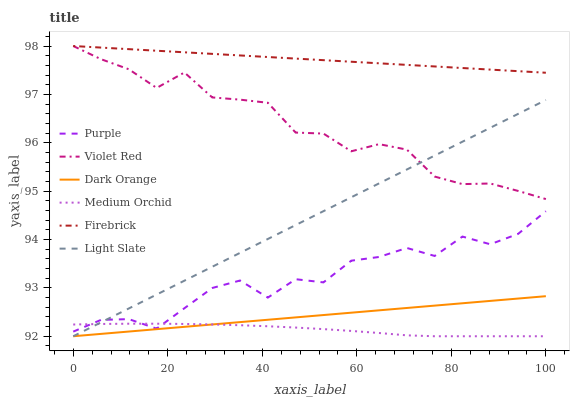Does Medium Orchid have the minimum area under the curve?
Answer yes or no. Yes. Does Firebrick have the maximum area under the curve?
Answer yes or no. Yes. Does Violet Red have the minimum area under the curve?
Answer yes or no. No. Does Violet Red have the maximum area under the curve?
Answer yes or no. No. Is Dark Orange the smoothest?
Answer yes or no. Yes. Is Purple the roughest?
Answer yes or no. Yes. Is Violet Red the smoothest?
Answer yes or no. No. Is Violet Red the roughest?
Answer yes or no. No. Does Dark Orange have the lowest value?
Answer yes or no. Yes. Does Violet Red have the lowest value?
Answer yes or no. No. Does Firebrick have the highest value?
Answer yes or no. Yes. Does Purple have the highest value?
Answer yes or no. No. Is Purple less than Firebrick?
Answer yes or no. Yes. Is Firebrick greater than Medium Orchid?
Answer yes or no. Yes. Does Dark Orange intersect Light Slate?
Answer yes or no. Yes. Is Dark Orange less than Light Slate?
Answer yes or no. No. Is Dark Orange greater than Light Slate?
Answer yes or no. No. Does Purple intersect Firebrick?
Answer yes or no. No. 